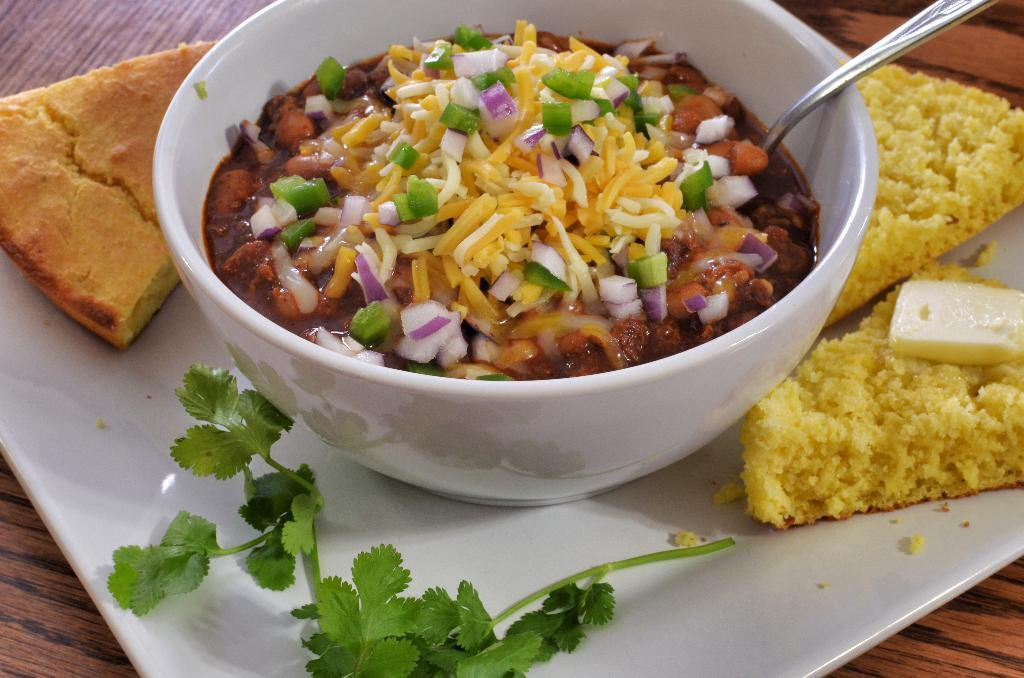What type of surface is visible in the image? There is a wooden platform in the image. What is placed on the wooden platform? There is food on the wooden platform, including coriander leaves in a plate. What else can be seen in the image besides the wooden platform? There is a bowl in the image, which contains food and has a spoon inside. What type of roof can be seen in the image? There is no roof present in the image; it features a wooden platform with food and a bowl. 